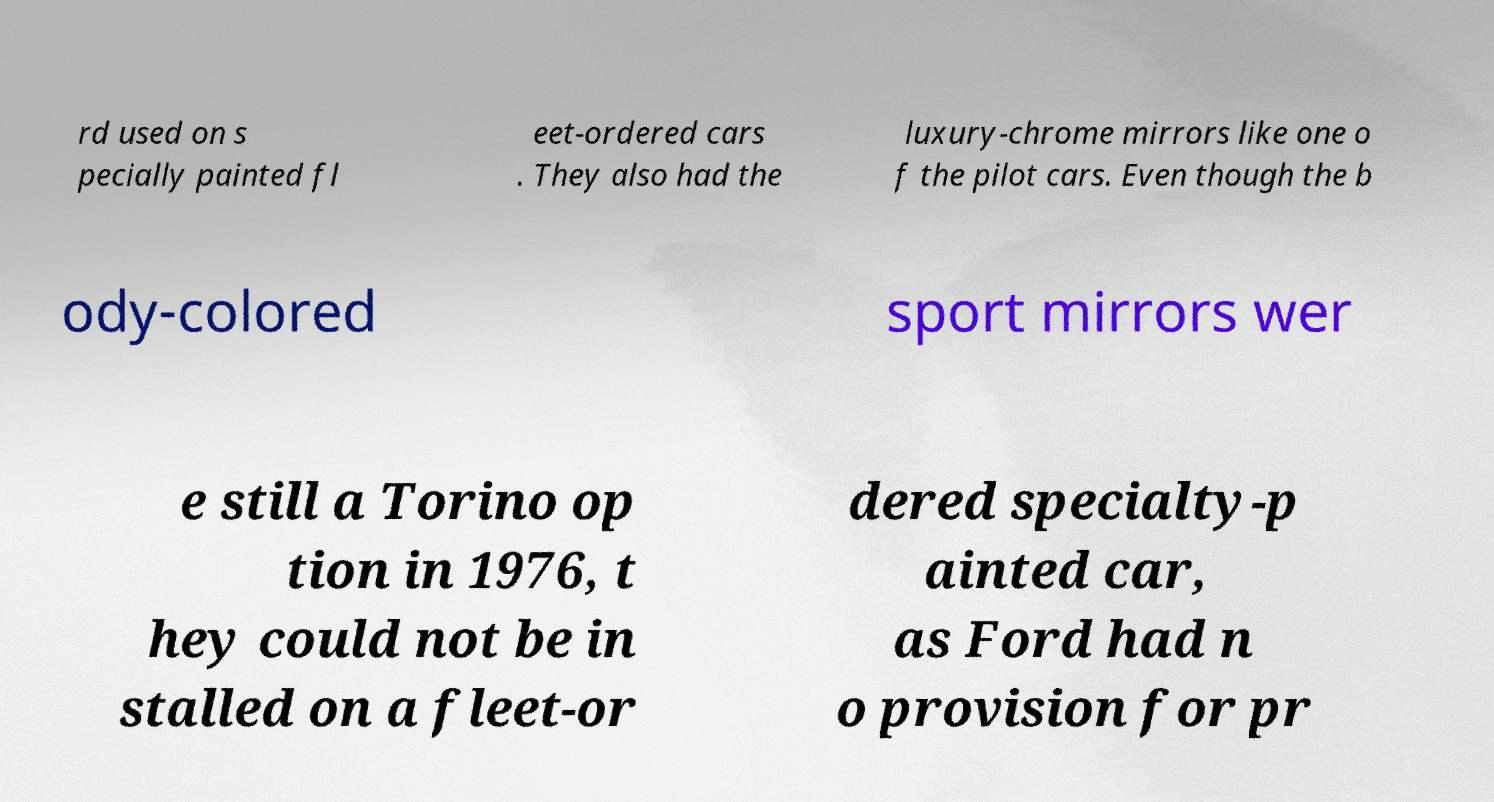I need the written content from this picture converted into text. Can you do that? rd used on s pecially painted fl eet-ordered cars . They also had the luxury-chrome mirrors like one o f the pilot cars. Even though the b ody-colored sport mirrors wer e still a Torino op tion in 1976, t hey could not be in stalled on a fleet-or dered specialty-p ainted car, as Ford had n o provision for pr 